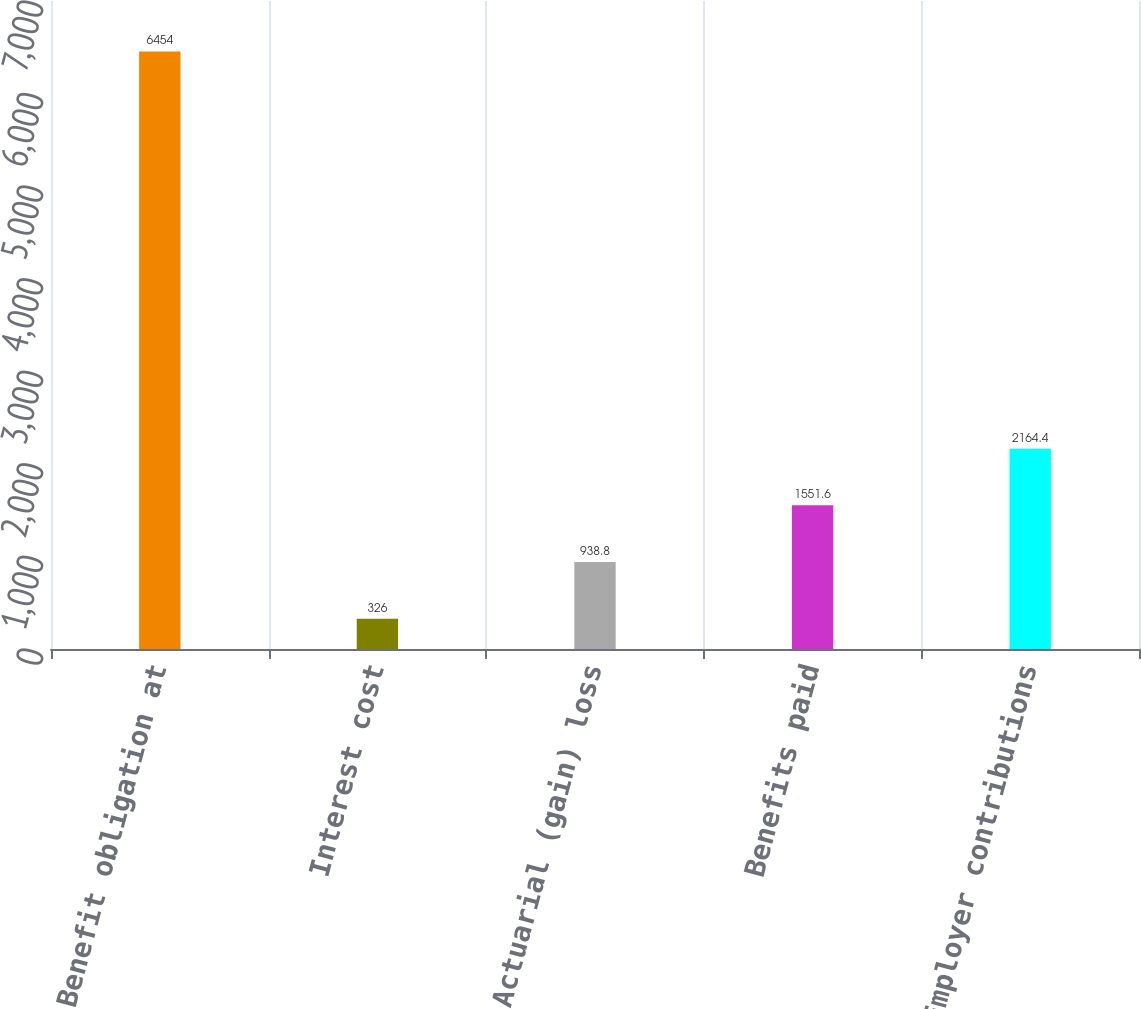Convert chart. <chart><loc_0><loc_0><loc_500><loc_500><bar_chart><fcel>Benefit obligation at<fcel>Interest cost<fcel>Actuarial (gain) loss<fcel>Benefits paid<fcel>Employer contributions<nl><fcel>6454<fcel>326<fcel>938.8<fcel>1551.6<fcel>2164.4<nl></chart> 